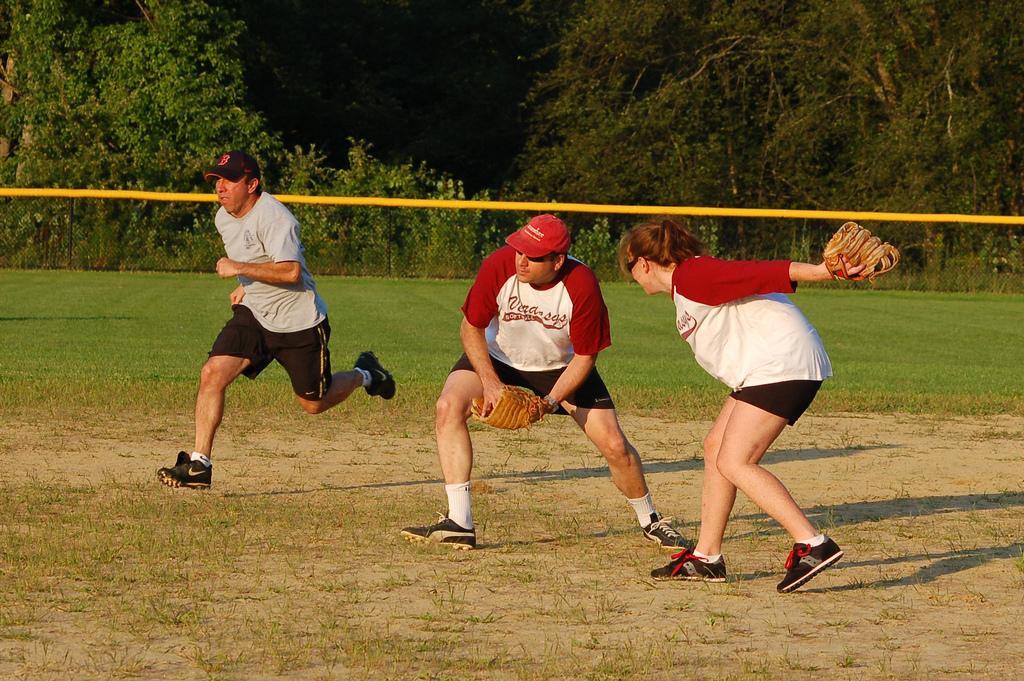How would you summarize this image in a sentence or two? In the picture there are total three people, two men and a woman. One of the man is running on the ground and the remaining two are playing. Around the ground there are a lot of trees. 